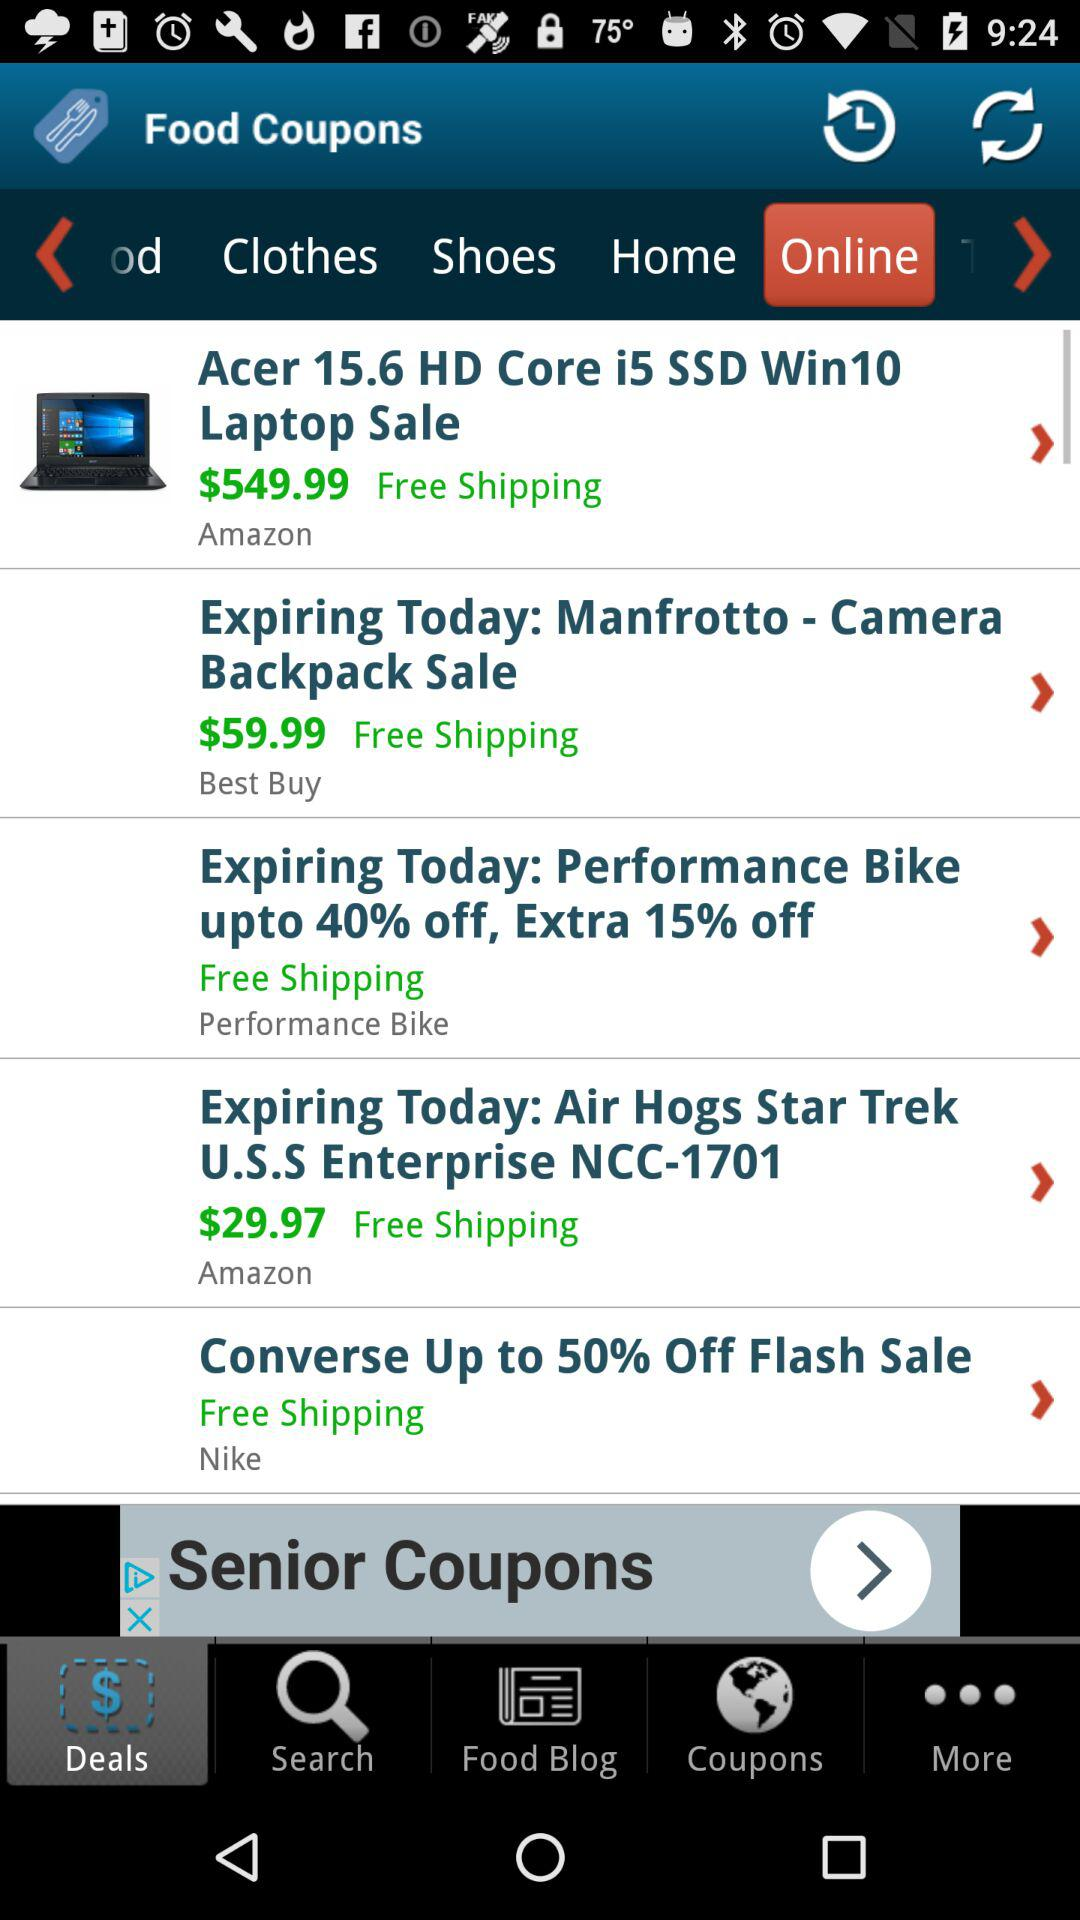What percentage is off on the sale of "Converse"? The percentage off on the sale of "Converse" is up to 50. 